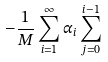<formula> <loc_0><loc_0><loc_500><loc_500>- \frac { 1 } { M } \sum _ { i = 1 } ^ { \infty } \alpha _ { i } \sum _ { j = 0 } ^ { i - 1 }</formula> 